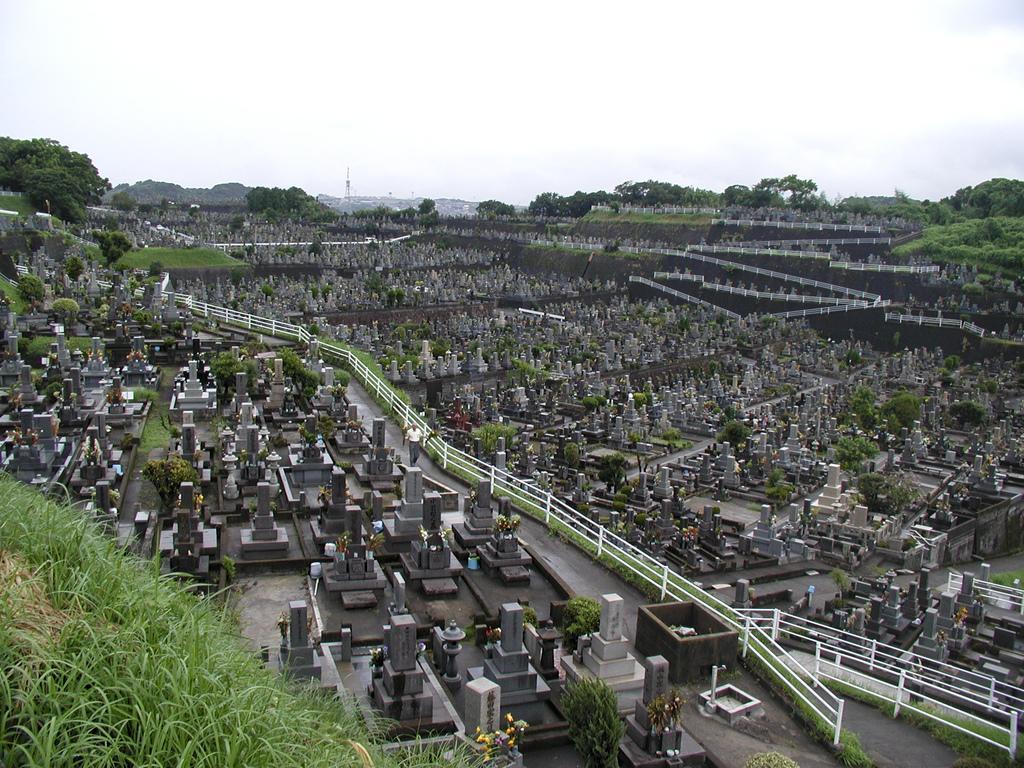In one or two sentences, can you explain what this image depicts? In this image I can see a group of buildings and I can see a person in the middle and I can see grass at the bottom , at the top I can see the sky and trees. 